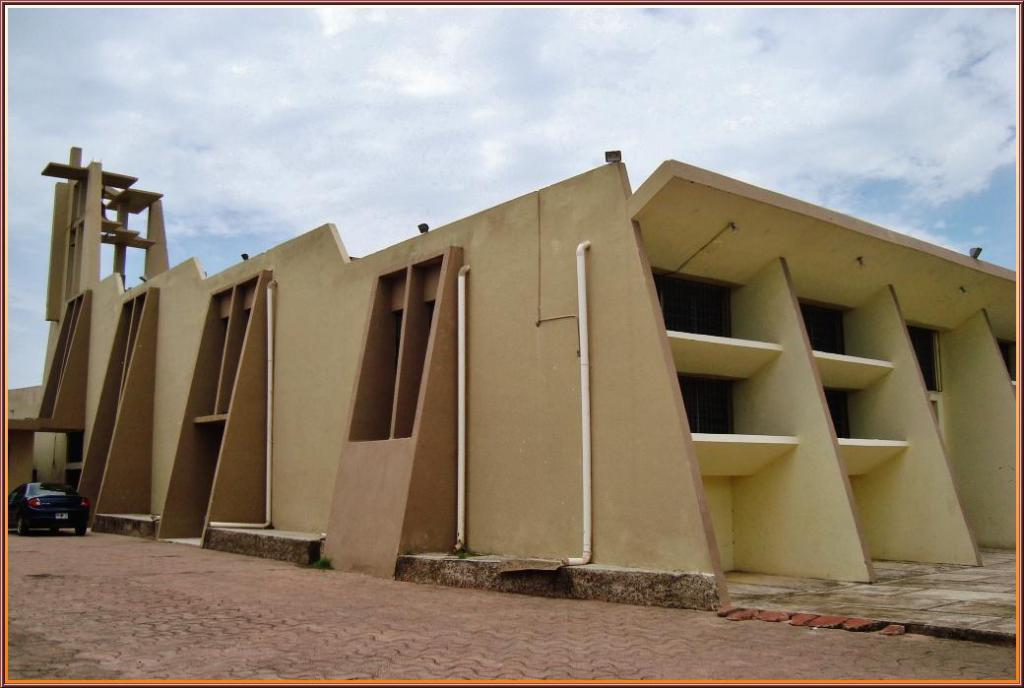What type of structure is present in the image? There is a building in the image. What can be seen on the left side of the image? There is a black color car on the left side of the image. What is visible at the top of the image? The sky is visible at the top of the image. What type of skin is visible on the building in the image? There is no skin visible on the building in the image; it is a structure made of materials like brick, concrete, or glass. What invention is being used by the car in the image? The car in the image is a regular automobile, and there is no specific invention being showcased or used by the car. 